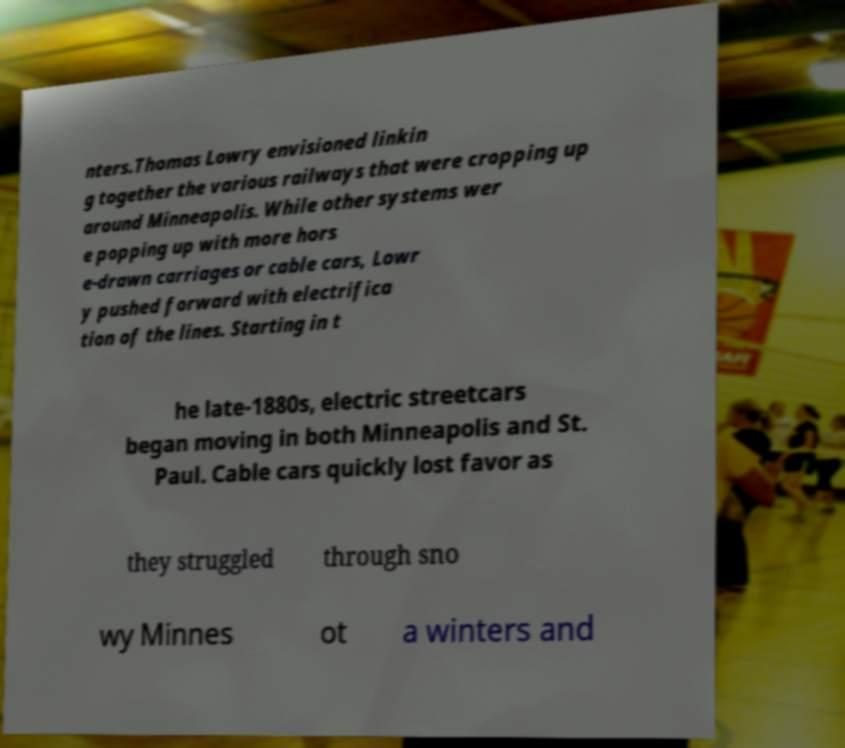Could you extract and type out the text from this image? nters.Thomas Lowry envisioned linkin g together the various railways that were cropping up around Minneapolis. While other systems wer e popping up with more hors e-drawn carriages or cable cars, Lowr y pushed forward with electrifica tion of the lines. Starting in t he late-1880s, electric streetcars began moving in both Minneapolis and St. Paul. Cable cars quickly lost favor as they struggled through sno wy Minnes ot a winters and 